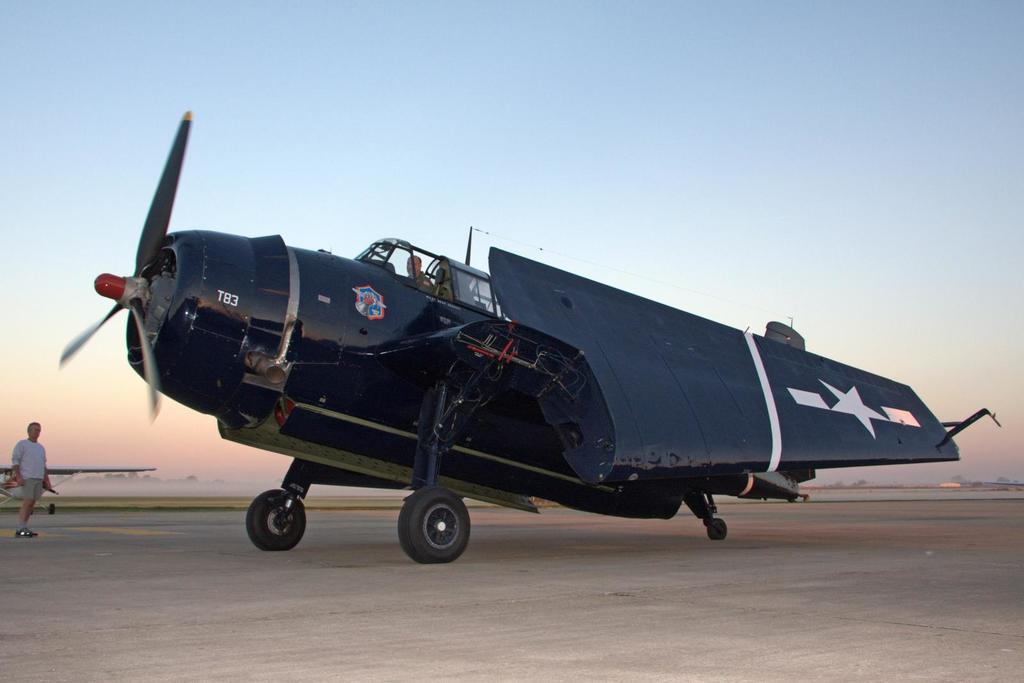<image>
Render a clear and concise summary of the photo. A plane with the number T83 on the nose is on the tarmac and its wings are folded. 